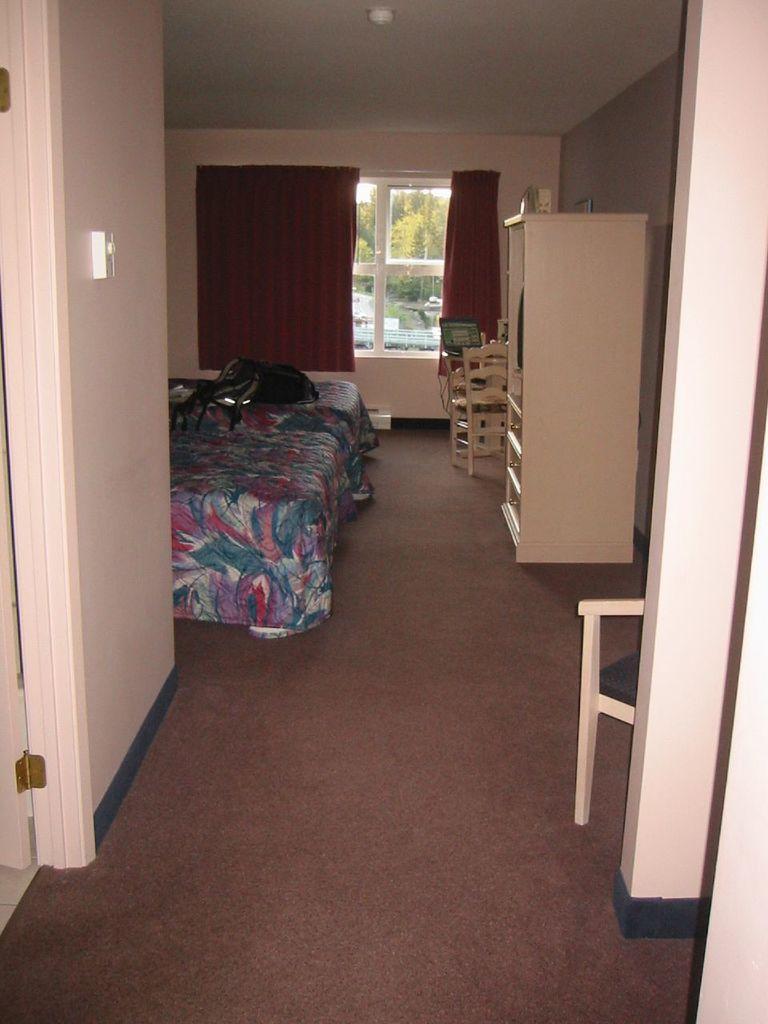Can you describe this image briefly? This image is clicked inside view of the room, in the room there is a cot on which there is a bed sheet, door, cupboard, chairs, window, curtain, wall, through window I can see trees, water, on the cot there is an object. 